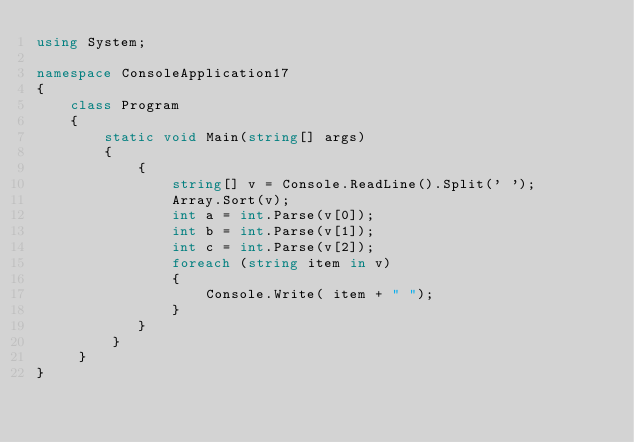Convert code to text. <code><loc_0><loc_0><loc_500><loc_500><_C#_>using System;

namespace ConsoleApplication17
{
    class Program
    {
        static void Main(string[] args)
        {
            {
                string[] v = Console.ReadLine().Split(' ');
                Array.Sort(v);
                int a = int.Parse(v[0]);
                int b = int.Parse(v[1]);
                int c = int.Parse(v[2]);
                foreach (string item in v)
                {
                    Console.Write( item + " ");
                }
            }
         }
     }
}</code> 